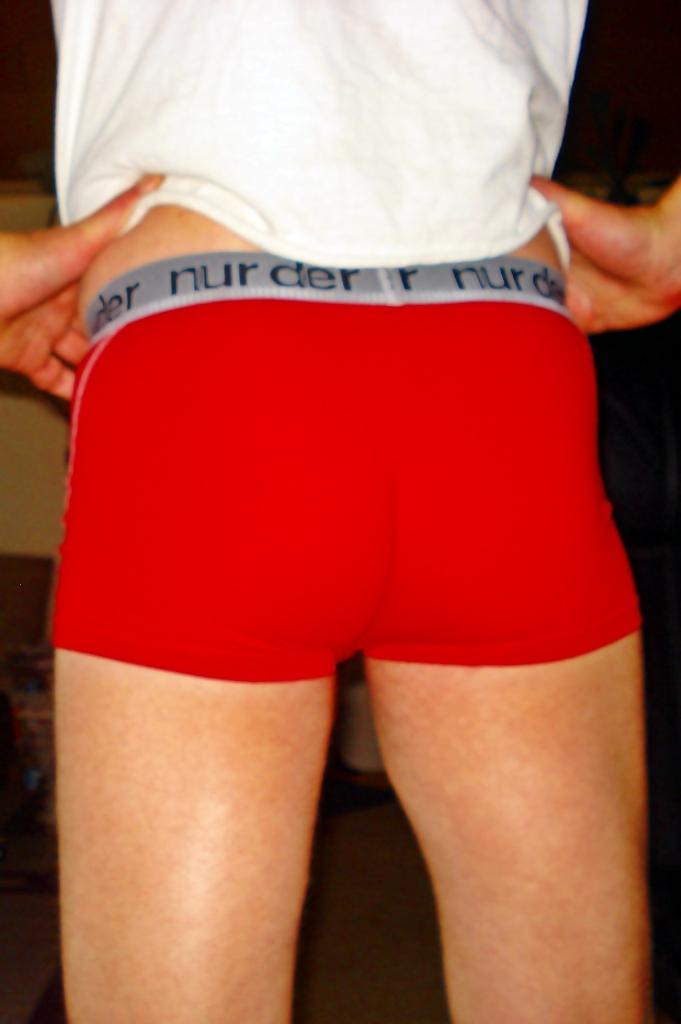Provide a one-sentence caption for the provided image. Man wearing underwear that says "nurder" on the strap. 